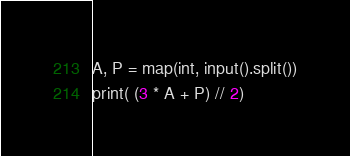Convert code to text. <code><loc_0><loc_0><loc_500><loc_500><_Python_>A, P = map(int, input().split())
print( (3 * A + P) // 2)</code> 